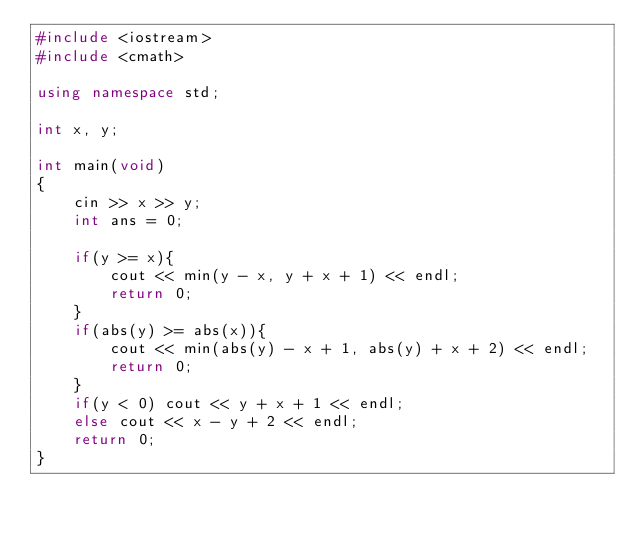Convert code to text. <code><loc_0><loc_0><loc_500><loc_500><_C++_>#include <iostream>
#include <cmath>

using namespace std;

int x, y;

int main(void)
{
	cin >> x >> y;
	int ans = 0;
	
	if(y >= x){
		cout << min(y - x, y + x + 1) << endl;
		return 0;
	}
	if(abs(y) >= abs(x)){
		cout << min(abs(y) - x + 1, abs(y) + x + 2) << endl;
		return 0;
	}
	if(y < 0) cout << y + x + 1 << endl;
	else cout << x - y + 2 << endl;
	return 0;
}</code> 